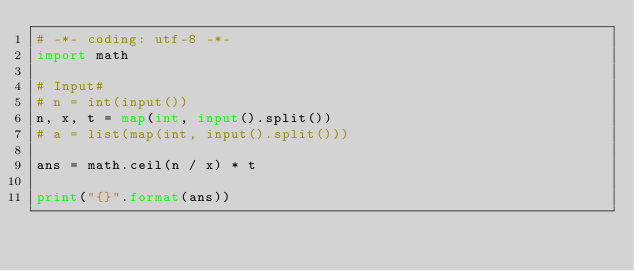Convert code to text. <code><loc_0><loc_0><loc_500><loc_500><_Python_># -*- coding: utf-8 -*-
import math

# Input#
# n = int(input())
n, x, t = map(int, input().split())
# a = list(map(int, input().split()))

ans = math.ceil(n / x) * t

print("{}".format(ans))
</code> 